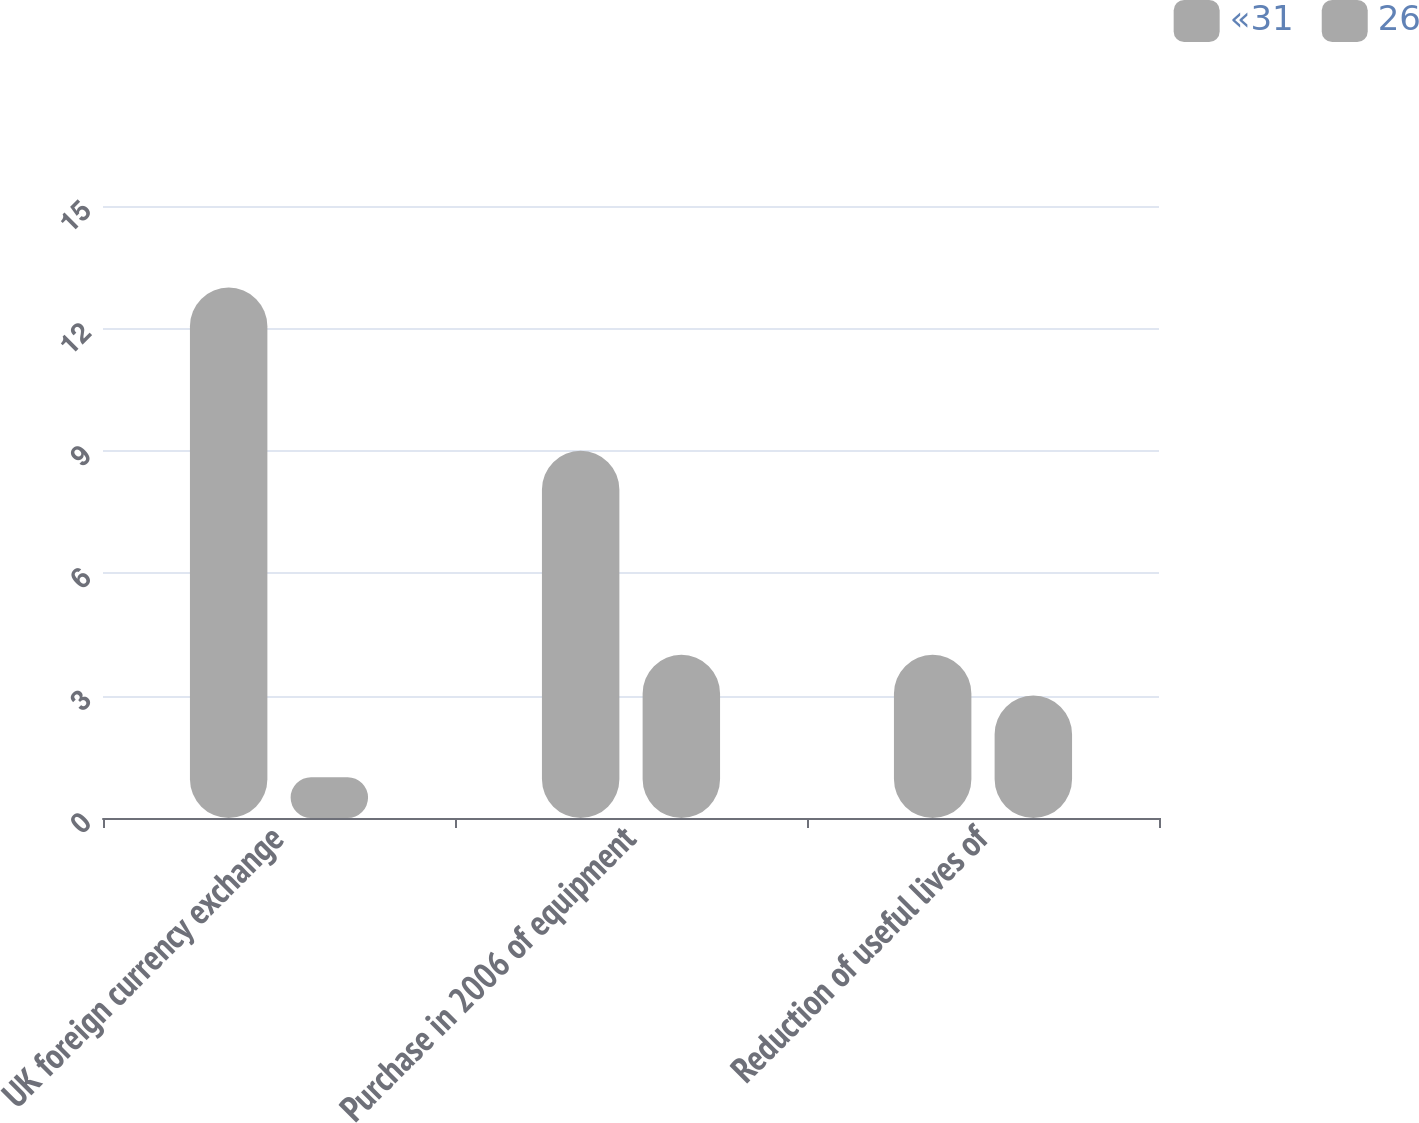Convert chart. <chart><loc_0><loc_0><loc_500><loc_500><stacked_bar_chart><ecel><fcel>UK foreign currency exchange<fcel>Purchase in 2006 of equipment<fcel>Reduction of useful lives of<nl><fcel>«31<fcel>13<fcel>9<fcel>4<nl><fcel>26<fcel>1<fcel>4<fcel>3<nl></chart> 